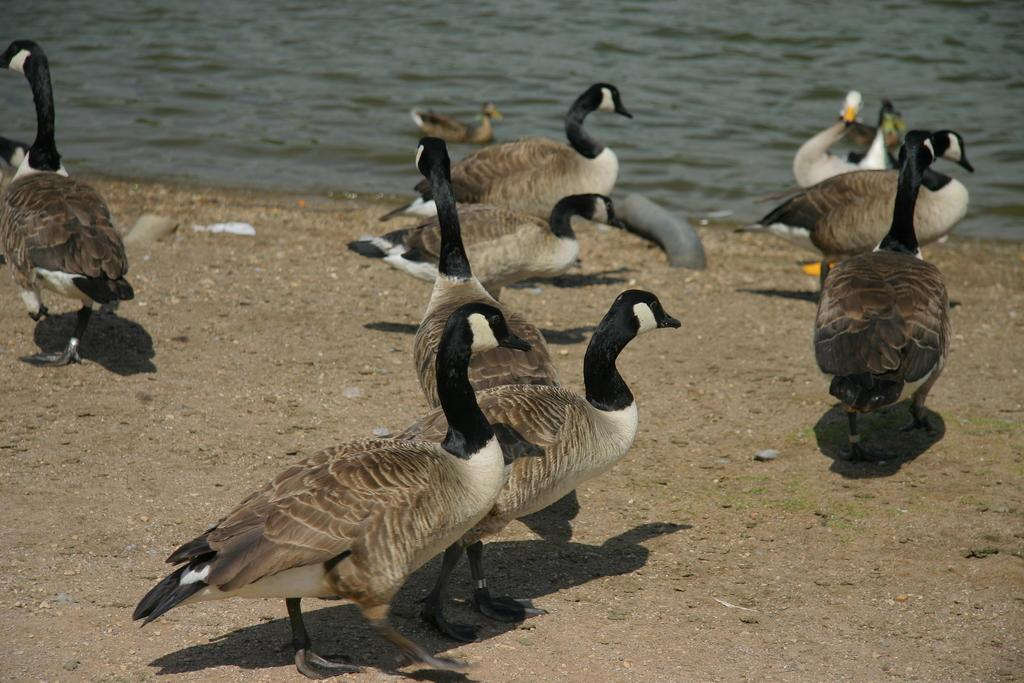What animals can be seen in the front of the image? There are birds in the front of the image. What natural element is visible in the background of the image? There is water visible in the background of the image. What type of tree can be seen in the image? There is no tree present in the image; it features birds in the front and water in the background. 